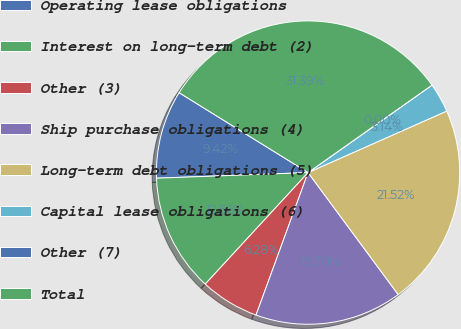Convert chart to OTSL. <chart><loc_0><loc_0><loc_500><loc_500><pie_chart><fcel>Operating lease obligations<fcel>Interest on long-term debt (2)<fcel>Other (3)<fcel>Ship purchase obligations (4)<fcel>Long-term debt obligations (5)<fcel>Capital lease obligations (6)<fcel>Other (7)<fcel>Total<nl><fcel>9.42%<fcel>12.56%<fcel>6.28%<fcel>15.7%<fcel>21.52%<fcel>3.14%<fcel>0.0%<fcel>31.39%<nl></chart> 